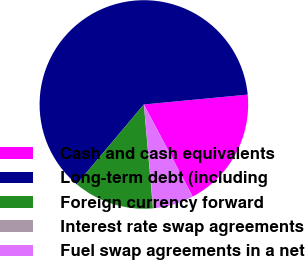<chart> <loc_0><loc_0><loc_500><loc_500><pie_chart><fcel>Cash and cash equivalents<fcel>Long-term debt (including<fcel>Foreign currency forward<fcel>Interest rate swap agreements<fcel>Fuel swap agreements in a net<nl><fcel>18.75%<fcel>62.36%<fcel>12.53%<fcel>0.07%<fcel>6.3%<nl></chart> 